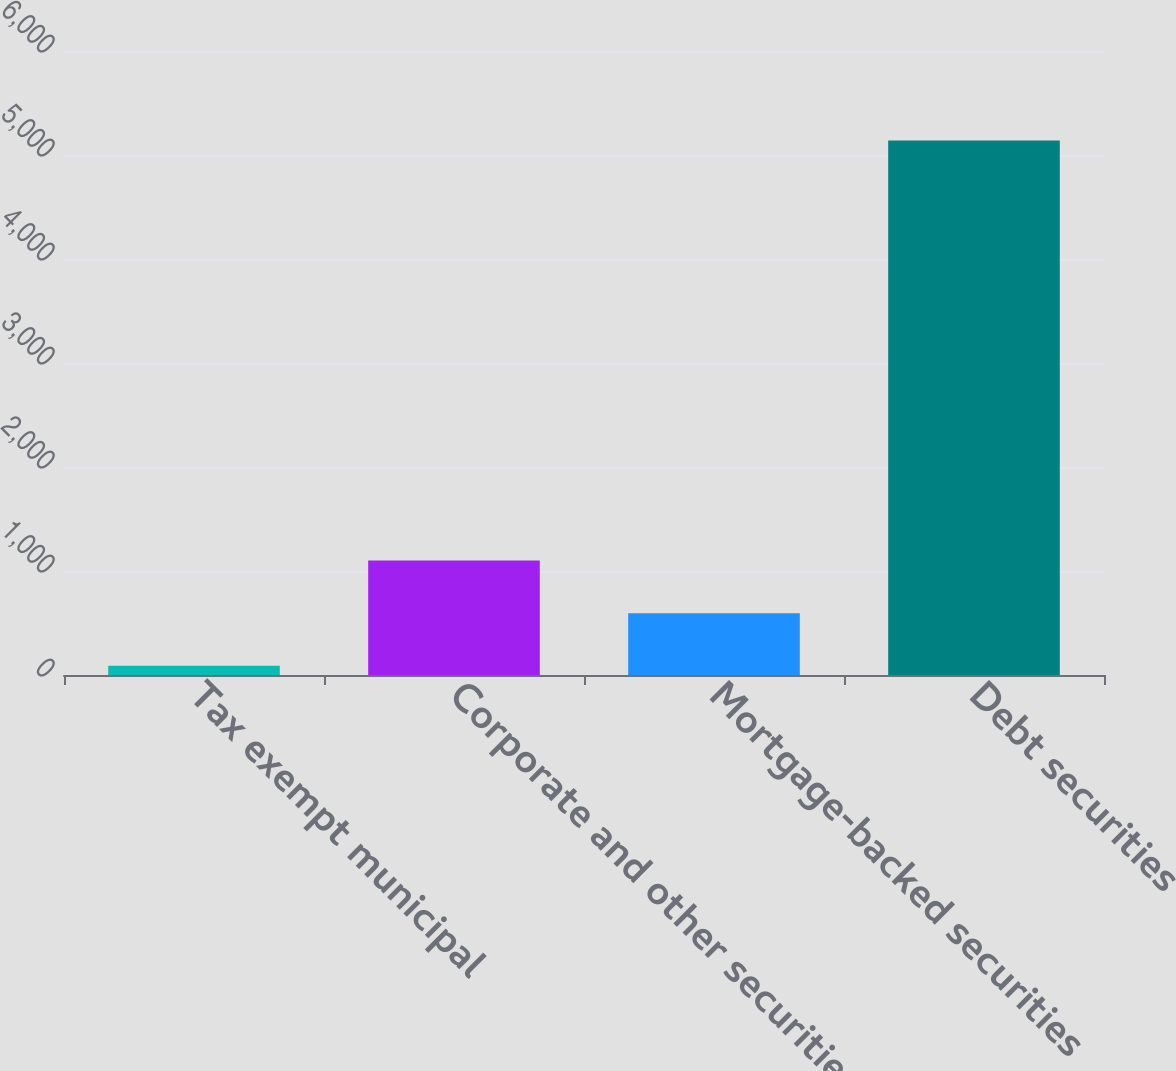<chart> <loc_0><loc_0><loc_500><loc_500><bar_chart><fcel>Tax exempt municipal<fcel>Corporate and other securities<fcel>Mortgage-backed securities<fcel>Debt securities<nl><fcel>90<fcel>1099.8<fcel>594.9<fcel>5139<nl></chart> 